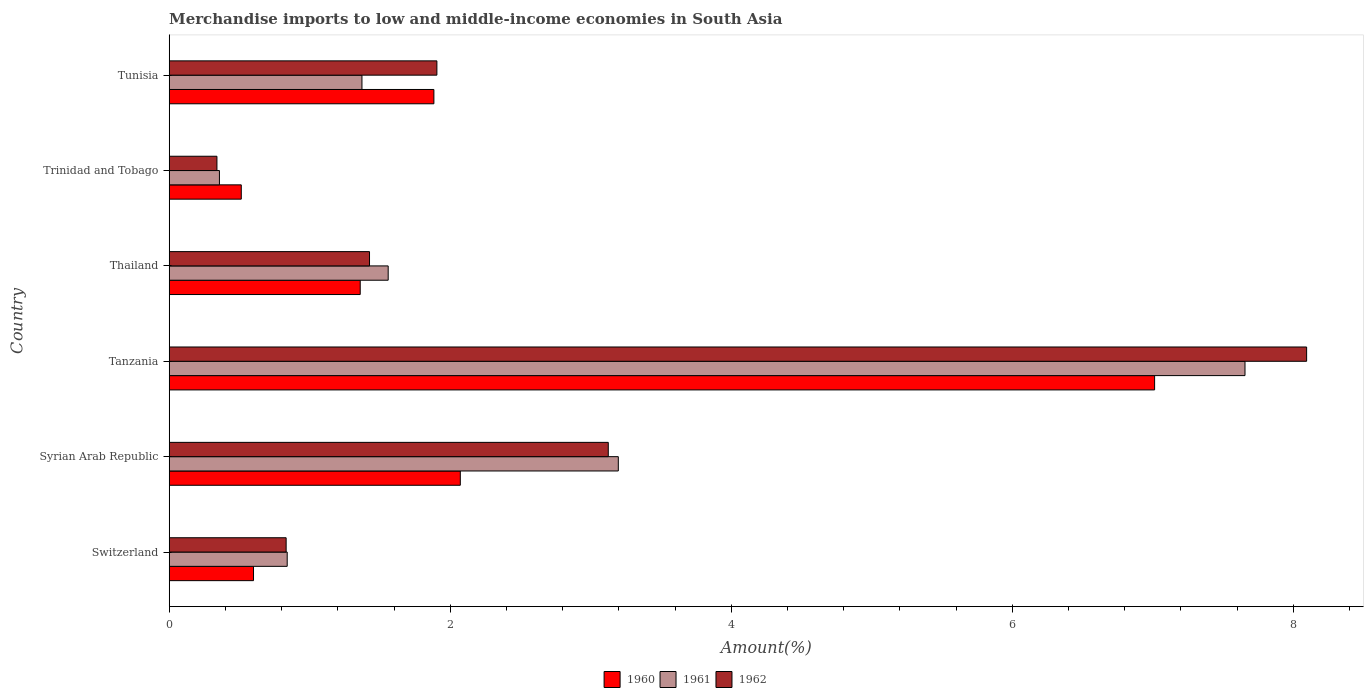How many bars are there on the 3rd tick from the bottom?
Keep it short and to the point. 3. What is the label of the 3rd group of bars from the top?
Provide a succinct answer. Thailand. In how many cases, is the number of bars for a given country not equal to the number of legend labels?
Your response must be concise. 0. What is the percentage of amount earned from merchandise imports in 1961 in Tunisia?
Offer a very short reply. 1.37. Across all countries, what is the maximum percentage of amount earned from merchandise imports in 1961?
Your answer should be very brief. 7.66. Across all countries, what is the minimum percentage of amount earned from merchandise imports in 1962?
Ensure brevity in your answer.  0.34. In which country was the percentage of amount earned from merchandise imports in 1960 maximum?
Ensure brevity in your answer.  Tanzania. In which country was the percentage of amount earned from merchandise imports in 1961 minimum?
Offer a very short reply. Trinidad and Tobago. What is the total percentage of amount earned from merchandise imports in 1961 in the graph?
Ensure brevity in your answer.  14.98. What is the difference between the percentage of amount earned from merchandise imports in 1960 in Thailand and that in Tunisia?
Give a very brief answer. -0.52. What is the difference between the percentage of amount earned from merchandise imports in 1960 in Tunisia and the percentage of amount earned from merchandise imports in 1961 in Syrian Arab Republic?
Your answer should be compact. -1.31. What is the average percentage of amount earned from merchandise imports in 1961 per country?
Your answer should be compact. 2.5. What is the difference between the percentage of amount earned from merchandise imports in 1960 and percentage of amount earned from merchandise imports in 1962 in Switzerland?
Your response must be concise. -0.23. What is the ratio of the percentage of amount earned from merchandise imports in 1962 in Syrian Arab Republic to that in Trinidad and Tobago?
Provide a succinct answer. 9.2. Is the difference between the percentage of amount earned from merchandise imports in 1960 in Switzerland and Tanzania greater than the difference between the percentage of amount earned from merchandise imports in 1962 in Switzerland and Tanzania?
Give a very brief answer. Yes. What is the difference between the highest and the second highest percentage of amount earned from merchandise imports in 1961?
Keep it short and to the point. 4.46. What is the difference between the highest and the lowest percentage of amount earned from merchandise imports in 1961?
Your answer should be very brief. 7.3. In how many countries, is the percentage of amount earned from merchandise imports in 1962 greater than the average percentage of amount earned from merchandise imports in 1962 taken over all countries?
Ensure brevity in your answer.  2. Is the sum of the percentage of amount earned from merchandise imports in 1960 in Switzerland and Syrian Arab Republic greater than the maximum percentage of amount earned from merchandise imports in 1962 across all countries?
Give a very brief answer. No. Is it the case that in every country, the sum of the percentage of amount earned from merchandise imports in 1962 and percentage of amount earned from merchandise imports in 1960 is greater than the percentage of amount earned from merchandise imports in 1961?
Give a very brief answer. Yes. How many bars are there?
Your answer should be very brief. 18. Are all the bars in the graph horizontal?
Provide a succinct answer. Yes. How many countries are there in the graph?
Provide a succinct answer. 6. Are the values on the major ticks of X-axis written in scientific E-notation?
Offer a terse response. No. Does the graph contain grids?
Give a very brief answer. No. Where does the legend appear in the graph?
Your response must be concise. Bottom center. What is the title of the graph?
Provide a short and direct response. Merchandise imports to low and middle-income economies in South Asia. What is the label or title of the X-axis?
Provide a succinct answer. Amount(%). What is the Amount(%) in 1960 in Switzerland?
Your answer should be very brief. 0.6. What is the Amount(%) in 1961 in Switzerland?
Your response must be concise. 0.84. What is the Amount(%) in 1962 in Switzerland?
Keep it short and to the point. 0.83. What is the Amount(%) of 1960 in Syrian Arab Republic?
Ensure brevity in your answer.  2.07. What is the Amount(%) of 1961 in Syrian Arab Republic?
Give a very brief answer. 3.2. What is the Amount(%) in 1962 in Syrian Arab Republic?
Provide a short and direct response. 3.12. What is the Amount(%) in 1960 in Tanzania?
Your answer should be very brief. 7.01. What is the Amount(%) in 1961 in Tanzania?
Make the answer very short. 7.66. What is the Amount(%) of 1962 in Tanzania?
Your response must be concise. 8.1. What is the Amount(%) of 1960 in Thailand?
Make the answer very short. 1.36. What is the Amount(%) of 1961 in Thailand?
Give a very brief answer. 1.56. What is the Amount(%) in 1962 in Thailand?
Offer a very short reply. 1.43. What is the Amount(%) in 1960 in Trinidad and Tobago?
Provide a short and direct response. 0.51. What is the Amount(%) of 1961 in Trinidad and Tobago?
Make the answer very short. 0.36. What is the Amount(%) of 1962 in Trinidad and Tobago?
Offer a terse response. 0.34. What is the Amount(%) in 1960 in Tunisia?
Ensure brevity in your answer.  1.88. What is the Amount(%) of 1961 in Tunisia?
Offer a terse response. 1.37. What is the Amount(%) of 1962 in Tunisia?
Your response must be concise. 1.91. Across all countries, what is the maximum Amount(%) of 1960?
Give a very brief answer. 7.01. Across all countries, what is the maximum Amount(%) in 1961?
Keep it short and to the point. 7.66. Across all countries, what is the maximum Amount(%) of 1962?
Make the answer very short. 8.1. Across all countries, what is the minimum Amount(%) of 1960?
Your answer should be compact. 0.51. Across all countries, what is the minimum Amount(%) in 1961?
Make the answer very short. 0.36. Across all countries, what is the minimum Amount(%) in 1962?
Your answer should be very brief. 0.34. What is the total Amount(%) of 1960 in the graph?
Offer a terse response. 13.44. What is the total Amount(%) of 1961 in the graph?
Your response must be concise. 14.98. What is the total Amount(%) of 1962 in the graph?
Your answer should be very brief. 15.72. What is the difference between the Amount(%) in 1960 in Switzerland and that in Syrian Arab Republic?
Give a very brief answer. -1.47. What is the difference between the Amount(%) in 1961 in Switzerland and that in Syrian Arab Republic?
Provide a succinct answer. -2.36. What is the difference between the Amount(%) of 1962 in Switzerland and that in Syrian Arab Republic?
Give a very brief answer. -2.29. What is the difference between the Amount(%) of 1960 in Switzerland and that in Tanzania?
Your response must be concise. -6.41. What is the difference between the Amount(%) in 1961 in Switzerland and that in Tanzania?
Your answer should be very brief. -6.82. What is the difference between the Amount(%) in 1962 in Switzerland and that in Tanzania?
Ensure brevity in your answer.  -7.26. What is the difference between the Amount(%) in 1960 in Switzerland and that in Thailand?
Your response must be concise. -0.76. What is the difference between the Amount(%) of 1961 in Switzerland and that in Thailand?
Make the answer very short. -0.72. What is the difference between the Amount(%) of 1962 in Switzerland and that in Thailand?
Your response must be concise. -0.59. What is the difference between the Amount(%) of 1960 in Switzerland and that in Trinidad and Tobago?
Ensure brevity in your answer.  0.09. What is the difference between the Amount(%) of 1961 in Switzerland and that in Trinidad and Tobago?
Ensure brevity in your answer.  0.48. What is the difference between the Amount(%) in 1962 in Switzerland and that in Trinidad and Tobago?
Your response must be concise. 0.49. What is the difference between the Amount(%) in 1960 in Switzerland and that in Tunisia?
Provide a short and direct response. -1.28. What is the difference between the Amount(%) in 1961 in Switzerland and that in Tunisia?
Provide a short and direct response. -0.53. What is the difference between the Amount(%) in 1962 in Switzerland and that in Tunisia?
Offer a terse response. -1.07. What is the difference between the Amount(%) in 1960 in Syrian Arab Republic and that in Tanzania?
Make the answer very short. -4.94. What is the difference between the Amount(%) in 1961 in Syrian Arab Republic and that in Tanzania?
Your answer should be compact. -4.46. What is the difference between the Amount(%) in 1962 in Syrian Arab Republic and that in Tanzania?
Your answer should be very brief. -4.97. What is the difference between the Amount(%) of 1960 in Syrian Arab Republic and that in Thailand?
Give a very brief answer. 0.71. What is the difference between the Amount(%) in 1961 in Syrian Arab Republic and that in Thailand?
Give a very brief answer. 1.64. What is the difference between the Amount(%) in 1962 in Syrian Arab Republic and that in Thailand?
Ensure brevity in your answer.  1.7. What is the difference between the Amount(%) of 1960 in Syrian Arab Republic and that in Trinidad and Tobago?
Offer a terse response. 1.56. What is the difference between the Amount(%) of 1961 in Syrian Arab Republic and that in Trinidad and Tobago?
Your answer should be very brief. 2.84. What is the difference between the Amount(%) in 1962 in Syrian Arab Republic and that in Trinidad and Tobago?
Your answer should be compact. 2.79. What is the difference between the Amount(%) in 1960 in Syrian Arab Republic and that in Tunisia?
Offer a very short reply. 0.19. What is the difference between the Amount(%) of 1961 in Syrian Arab Republic and that in Tunisia?
Give a very brief answer. 1.82. What is the difference between the Amount(%) in 1962 in Syrian Arab Republic and that in Tunisia?
Offer a terse response. 1.22. What is the difference between the Amount(%) of 1960 in Tanzania and that in Thailand?
Give a very brief answer. 5.65. What is the difference between the Amount(%) of 1961 in Tanzania and that in Thailand?
Make the answer very short. 6.1. What is the difference between the Amount(%) of 1962 in Tanzania and that in Thailand?
Your answer should be very brief. 6.67. What is the difference between the Amount(%) in 1960 in Tanzania and that in Trinidad and Tobago?
Offer a terse response. 6.5. What is the difference between the Amount(%) of 1961 in Tanzania and that in Trinidad and Tobago?
Make the answer very short. 7.3. What is the difference between the Amount(%) of 1962 in Tanzania and that in Trinidad and Tobago?
Make the answer very short. 7.76. What is the difference between the Amount(%) of 1960 in Tanzania and that in Tunisia?
Your response must be concise. 5.13. What is the difference between the Amount(%) in 1961 in Tanzania and that in Tunisia?
Offer a very short reply. 6.28. What is the difference between the Amount(%) of 1962 in Tanzania and that in Tunisia?
Your answer should be very brief. 6.19. What is the difference between the Amount(%) of 1960 in Thailand and that in Trinidad and Tobago?
Offer a terse response. 0.85. What is the difference between the Amount(%) of 1961 in Thailand and that in Trinidad and Tobago?
Provide a short and direct response. 1.2. What is the difference between the Amount(%) in 1962 in Thailand and that in Trinidad and Tobago?
Offer a terse response. 1.09. What is the difference between the Amount(%) in 1960 in Thailand and that in Tunisia?
Your response must be concise. -0.52. What is the difference between the Amount(%) of 1961 in Thailand and that in Tunisia?
Your response must be concise. 0.19. What is the difference between the Amount(%) of 1962 in Thailand and that in Tunisia?
Make the answer very short. -0.48. What is the difference between the Amount(%) in 1960 in Trinidad and Tobago and that in Tunisia?
Ensure brevity in your answer.  -1.37. What is the difference between the Amount(%) in 1961 in Trinidad and Tobago and that in Tunisia?
Give a very brief answer. -1.01. What is the difference between the Amount(%) in 1962 in Trinidad and Tobago and that in Tunisia?
Offer a very short reply. -1.57. What is the difference between the Amount(%) in 1960 in Switzerland and the Amount(%) in 1961 in Syrian Arab Republic?
Make the answer very short. -2.6. What is the difference between the Amount(%) in 1960 in Switzerland and the Amount(%) in 1962 in Syrian Arab Republic?
Keep it short and to the point. -2.52. What is the difference between the Amount(%) of 1961 in Switzerland and the Amount(%) of 1962 in Syrian Arab Republic?
Offer a terse response. -2.29. What is the difference between the Amount(%) in 1960 in Switzerland and the Amount(%) in 1961 in Tanzania?
Give a very brief answer. -7.06. What is the difference between the Amount(%) in 1960 in Switzerland and the Amount(%) in 1962 in Tanzania?
Make the answer very short. -7.5. What is the difference between the Amount(%) in 1961 in Switzerland and the Amount(%) in 1962 in Tanzania?
Your answer should be very brief. -7.26. What is the difference between the Amount(%) of 1960 in Switzerland and the Amount(%) of 1961 in Thailand?
Ensure brevity in your answer.  -0.96. What is the difference between the Amount(%) of 1960 in Switzerland and the Amount(%) of 1962 in Thailand?
Offer a very short reply. -0.83. What is the difference between the Amount(%) of 1961 in Switzerland and the Amount(%) of 1962 in Thailand?
Provide a succinct answer. -0.59. What is the difference between the Amount(%) of 1960 in Switzerland and the Amount(%) of 1961 in Trinidad and Tobago?
Keep it short and to the point. 0.24. What is the difference between the Amount(%) in 1960 in Switzerland and the Amount(%) in 1962 in Trinidad and Tobago?
Give a very brief answer. 0.26. What is the difference between the Amount(%) in 1961 in Switzerland and the Amount(%) in 1962 in Trinidad and Tobago?
Provide a succinct answer. 0.5. What is the difference between the Amount(%) in 1960 in Switzerland and the Amount(%) in 1961 in Tunisia?
Your answer should be compact. -0.77. What is the difference between the Amount(%) of 1960 in Switzerland and the Amount(%) of 1962 in Tunisia?
Your answer should be compact. -1.31. What is the difference between the Amount(%) in 1961 in Switzerland and the Amount(%) in 1962 in Tunisia?
Offer a terse response. -1.07. What is the difference between the Amount(%) of 1960 in Syrian Arab Republic and the Amount(%) of 1961 in Tanzania?
Your answer should be compact. -5.58. What is the difference between the Amount(%) in 1960 in Syrian Arab Republic and the Amount(%) in 1962 in Tanzania?
Provide a succinct answer. -6.02. What is the difference between the Amount(%) in 1961 in Syrian Arab Republic and the Amount(%) in 1962 in Tanzania?
Your answer should be very brief. -4.9. What is the difference between the Amount(%) in 1960 in Syrian Arab Republic and the Amount(%) in 1961 in Thailand?
Ensure brevity in your answer.  0.51. What is the difference between the Amount(%) in 1960 in Syrian Arab Republic and the Amount(%) in 1962 in Thailand?
Make the answer very short. 0.65. What is the difference between the Amount(%) of 1961 in Syrian Arab Republic and the Amount(%) of 1962 in Thailand?
Offer a terse response. 1.77. What is the difference between the Amount(%) in 1960 in Syrian Arab Republic and the Amount(%) in 1961 in Trinidad and Tobago?
Offer a very short reply. 1.71. What is the difference between the Amount(%) of 1960 in Syrian Arab Republic and the Amount(%) of 1962 in Trinidad and Tobago?
Your answer should be very brief. 1.73. What is the difference between the Amount(%) of 1961 in Syrian Arab Republic and the Amount(%) of 1962 in Trinidad and Tobago?
Your answer should be very brief. 2.86. What is the difference between the Amount(%) in 1960 in Syrian Arab Republic and the Amount(%) in 1961 in Tunisia?
Provide a short and direct response. 0.7. What is the difference between the Amount(%) in 1961 in Syrian Arab Republic and the Amount(%) in 1962 in Tunisia?
Ensure brevity in your answer.  1.29. What is the difference between the Amount(%) in 1960 in Tanzania and the Amount(%) in 1961 in Thailand?
Your answer should be compact. 5.45. What is the difference between the Amount(%) in 1960 in Tanzania and the Amount(%) in 1962 in Thailand?
Offer a very short reply. 5.59. What is the difference between the Amount(%) of 1961 in Tanzania and the Amount(%) of 1962 in Thailand?
Your response must be concise. 6.23. What is the difference between the Amount(%) of 1960 in Tanzania and the Amount(%) of 1961 in Trinidad and Tobago?
Make the answer very short. 6.66. What is the difference between the Amount(%) in 1960 in Tanzania and the Amount(%) in 1962 in Trinidad and Tobago?
Keep it short and to the point. 6.67. What is the difference between the Amount(%) in 1961 in Tanzania and the Amount(%) in 1962 in Trinidad and Tobago?
Your response must be concise. 7.32. What is the difference between the Amount(%) of 1960 in Tanzania and the Amount(%) of 1961 in Tunisia?
Make the answer very short. 5.64. What is the difference between the Amount(%) in 1960 in Tanzania and the Amount(%) in 1962 in Tunisia?
Make the answer very short. 5.11. What is the difference between the Amount(%) in 1961 in Tanzania and the Amount(%) in 1962 in Tunisia?
Your response must be concise. 5.75. What is the difference between the Amount(%) of 1960 in Thailand and the Amount(%) of 1961 in Trinidad and Tobago?
Make the answer very short. 1. What is the difference between the Amount(%) in 1960 in Thailand and the Amount(%) in 1962 in Trinidad and Tobago?
Keep it short and to the point. 1.02. What is the difference between the Amount(%) in 1961 in Thailand and the Amount(%) in 1962 in Trinidad and Tobago?
Ensure brevity in your answer.  1.22. What is the difference between the Amount(%) in 1960 in Thailand and the Amount(%) in 1961 in Tunisia?
Your answer should be compact. -0.01. What is the difference between the Amount(%) in 1960 in Thailand and the Amount(%) in 1962 in Tunisia?
Ensure brevity in your answer.  -0.55. What is the difference between the Amount(%) in 1961 in Thailand and the Amount(%) in 1962 in Tunisia?
Make the answer very short. -0.35. What is the difference between the Amount(%) in 1960 in Trinidad and Tobago and the Amount(%) in 1961 in Tunisia?
Provide a short and direct response. -0.86. What is the difference between the Amount(%) in 1960 in Trinidad and Tobago and the Amount(%) in 1962 in Tunisia?
Your answer should be very brief. -1.39. What is the difference between the Amount(%) in 1961 in Trinidad and Tobago and the Amount(%) in 1962 in Tunisia?
Keep it short and to the point. -1.55. What is the average Amount(%) in 1960 per country?
Your answer should be compact. 2.24. What is the average Amount(%) of 1961 per country?
Provide a short and direct response. 2.5. What is the average Amount(%) in 1962 per country?
Offer a terse response. 2.62. What is the difference between the Amount(%) of 1960 and Amount(%) of 1961 in Switzerland?
Your response must be concise. -0.24. What is the difference between the Amount(%) of 1960 and Amount(%) of 1962 in Switzerland?
Make the answer very short. -0.23. What is the difference between the Amount(%) in 1961 and Amount(%) in 1962 in Switzerland?
Provide a succinct answer. 0.01. What is the difference between the Amount(%) of 1960 and Amount(%) of 1961 in Syrian Arab Republic?
Provide a short and direct response. -1.12. What is the difference between the Amount(%) in 1960 and Amount(%) in 1962 in Syrian Arab Republic?
Make the answer very short. -1.05. What is the difference between the Amount(%) of 1961 and Amount(%) of 1962 in Syrian Arab Republic?
Your response must be concise. 0.07. What is the difference between the Amount(%) in 1960 and Amount(%) in 1961 in Tanzania?
Ensure brevity in your answer.  -0.64. What is the difference between the Amount(%) in 1960 and Amount(%) in 1962 in Tanzania?
Your response must be concise. -1.08. What is the difference between the Amount(%) of 1961 and Amount(%) of 1962 in Tanzania?
Offer a terse response. -0.44. What is the difference between the Amount(%) in 1960 and Amount(%) in 1961 in Thailand?
Your response must be concise. -0.2. What is the difference between the Amount(%) in 1960 and Amount(%) in 1962 in Thailand?
Provide a succinct answer. -0.07. What is the difference between the Amount(%) of 1961 and Amount(%) of 1962 in Thailand?
Ensure brevity in your answer.  0.13. What is the difference between the Amount(%) in 1960 and Amount(%) in 1961 in Trinidad and Tobago?
Provide a short and direct response. 0.16. What is the difference between the Amount(%) in 1960 and Amount(%) in 1962 in Trinidad and Tobago?
Keep it short and to the point. 0.17. What is the difference between the Amount(%) in 1961 and Amount(%) in 1962 in Trinidad and Tobago?
Keep it short and to the point. 0.02. What is the difference between the Amount(%) of 1960 and Amount(%) of 1961 in Tunisia?
Your answer should be compact. 0.51. What is the difference between the Amount(%) of 1960 and Amount(%) of 1962 in Tunisia?
Your answer should be compact. -0.02. What is the difference between the Amount(%) in 1961 and Amount(%) in 1962 in Tunisia?
Make the answer very short. -0.53. What is the ratio of the Amount(%) in 1960 in Switzerland to that in Syrian Arab Republic?
Offer a terse response. 0.29. What is the ratio of the Amount(%) in 1961 in Switzerland to that in Syrian Arab Republic?
Your response must be concise. 0.26. What is the ratio of the Amount(%) of 1962 in Switzerland to that in Syrian Arab Republic?
Ensure brevity in your answer.  0.27. What is the ratio of the Amount(%) of 1960 in Switzerland to that in Tanzania?
Provide a short and direct response. 0.09. What is the ratio of the Amount(%) in 1961 in Switzerland to that in Tanzania?
Give a very brief answer. 0.11. What is the ratio of the Amount(%) in 1962 in Switzerland to that in Tanzania?
Give a very brief answer. 0.1. What is the ratio of the Amount(%) in 1960 in Switzerland to that in Thailand?
Provide a succinct answer. 0.44. What is the ratio of the Amount(%) of 1961 in Switzerland to that in Thailand?
Your response must be concise. 0.54. What is the ratio of the Amount(%) in 1962 in Switzerland to that in Thailand?
Provide a short and direct response. 0.58. What is the ratio of the Amount(%) of 1960 in Switzerland to that in Trinidad and Tobago?
Your response must be concise. 1.17. What is the ratio of the Amount(%) in 1961 in Switzerland to that in Trinidad and Tobago?
Your answer should be very brief. 2.35. What is the ratio of the Amount(%) in 1962 in Switzerland to that in Trinidad and Tobago?
Provide a short and direct response. 2.45. What is the ratio of the Amount(%) in 1960 in Switzerland to that in Tunisia?
Your answer should be compact. 0.32. What is the ratio of the Amount(%) of 1961 in Switzerland to that in Tunisia?
Your answer should be very brief. 0.61. What is the ratio of the Amount(%) in 1962 in Switzerland to that in Tunisia?
Offer a terse response. 0.44. What is the ratio of the Amount(%) in 1960 in Syrian Arab Republic to that in Tanzania?
Provide a succinct answer. 0.3. What is the ratio of the Amount(%) of 1961 in Syrian Arab Republic to that in Tanzania?
Make the answer very short. 0.42. What is the ratio of the Amount(%) in 1962 in Syrian Arab Republic to that in Tanzania?
Keep it short and to the point. 0.39. What is the ratio of the Amount(%) of 1960 in Syrian Arab Republic to that in Thailand?
Your response must be concise. 1.52. What is the ratio of the Amount(%) in 1961 in Syrian Arab Republic to that in Thailand?
Offer a very short reply. 2.05. What is the ratio of the Amount(%) of 1962 in Syrian Arab Republic to that in Thailand?
Your response must be concise. 2.19. What is the ratio of the Amount(%) of 1960 in Syrian Arab Republic to that in Trinidad and Tobago?
Your response must be concise. 4.04. What is the ratio of the Amount(%) in 1961 in Syrian Arab Republic to that in Trinidad and Tobago?
Offer a very short reply. 8.94. What is the ratio of the Amount(%) in 1962 in Syrian Arab Republic to that in Trinidad and Tobago?
Give a very brief answer. 9.2. What is the ratio of the Amount(%) of 1960 in Syrian Arab Republic to that in Tunisia?
Your answer should be compact. 1.1. What is the ratio of the Amount(%) of 1961 in Syrian Arab Republic to that in Tunisia?
Your response must be concise. 2.33. What is the ratio of the Amount(%) of 1962 in Syrian Arab Republic to that in Tunisia?
Your answer should be very brief. 1.64. What is the ratio of the Amount(%) of 1960 in Tanzania to that in Thailand?
Your answer should be compact. 5.16. What is the ratio of the Amount(%) in 1961 in Tanzania to that in Thailand?
Keep it short and to the point. 4.91. What is the ratio of the Amount(%) in 1962 in Tanzania to that in Thailand?
Your answer should be compact. 5.68. What is the ratio of the Amount(%) of 1960 in Tanzania to that in Trinidad and Tobago?
Provide a succinct answer. 13.67. What is the ratio of the Amount(%) of 1961 in Tanzania to that in Trinidad and Tobago?
Offer a very short reply. 21.42. What is the ratio of the Amount(%) in 1962 in Tanzania to that in Trinidad and Tobago?
Provide a short and direct response. 23.83. What is the ratio of the Amount(%) in 1960 in Tanzania to that in Tunisia?
Your answer should be very brief. 3.72. What is the ratio of the Amount(%) of 1961 in Tanzania to that in Tunisia?
Offer a very short reply. 5.58. What is the ratio of the Amount(%) of 1962 in Tanzania to that in Tunisia?
Ensure brevity in your answer.  4.25. What is the ratio of the Amount(%) in 1960 in Thailand to that in Trinidad and Tobago?
Your answer should be very brief. 2.65. What is the ratio of the Amount(%) of 1961 in Thailand to that in Trinidad and Tobago?
Offer a very short reply. 4.36. What is the ratio of the Amount(%) in 1962 in Thailand to that in Trinidad and Tobago?
Your response must be concise. 4.2. What is the ratio of the Amount(%) of 1960 in Thailand to that in Tunisia?
Ensure brevity in your answer.  0.72. What is the ratio of the Amount(%) of 1961 in Thailand to that in Tunisia?
Ensure brevity in your answer.  1.14. What is the ratio of the Amount(%) of 1962 in Thailand to that in Tunisia?
Provide a short and direct response. 0.75. What is the ratio of the Amount(%) in 1960 in Trinidad and Tobago to that in Tunisia?
Provide a succinct answer. 0.27. What is the ratio of the Amount(%) in 1961 in Trinidad and Tobago to that in Tunisia?
Provide a short and direct response. 0.26. What is the ratio of the Amount(%) of 1962 in Trinidad and Tobago to that in Tunisia?
Your answer should be very brief. 0.18. What is the difference between the highest and the second highest Amount(%) in 1960?
Give a very brief answer. 4.94. What is the difference between the highest and the second highest Amount(%) in 1961?
Your answer should be compact. 4.46. What is the difference between the highest and the second highest Amount(%) in 1962?
Your response must be concise. 4.97. What is the difference between the highest and the lowest Amount(%) of 1960?
Provide a succinct answer. 6.5. What is the difference between the highest and the lowest Amount(%) of 1961?
Offer a very short reply. 7.3. What is the difference between the highest and the lowest Amount(%) in 1962?
Keep it short and to the point. 7.76. 